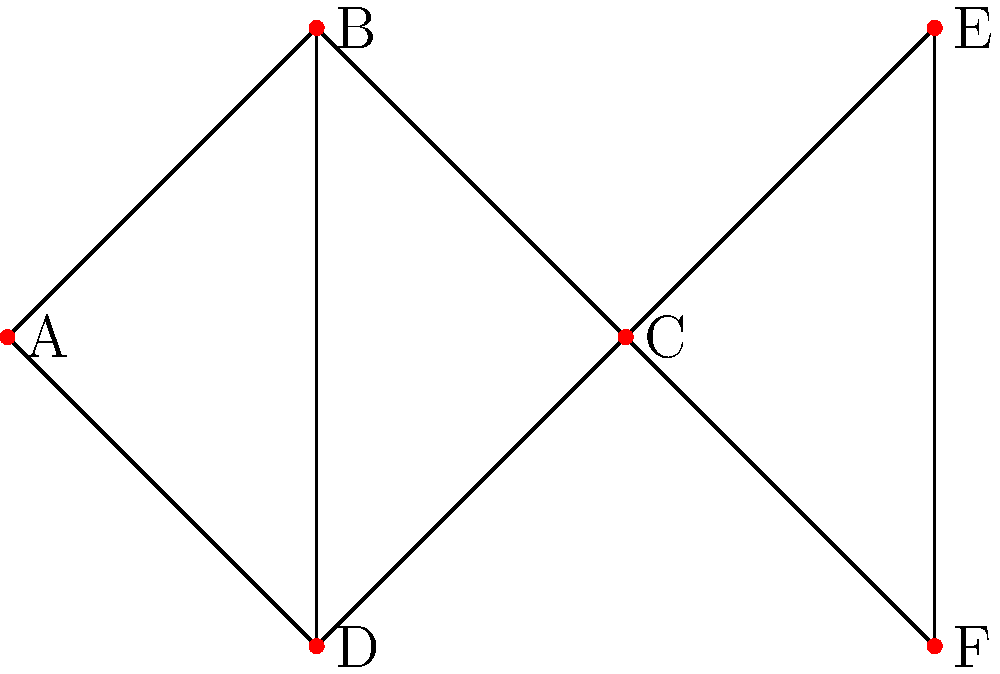As a proactive manager analyzing team communication channels, you're presented with the above undirected graph representing connections between team members. If team member C becomes unavailable, what is the minimum number of additional connections needed to ensure all remaining team members can still communicate with each other, either directly or indirectly? To solve this problem, we need to follow these steps:

1. Identify the current connections:
   - A is connected to B and D
   - B is connected to A, C, and D
   - C is connected to B, E, and F
   - D is connected to A and B
   - E is connected to C and F
   - F is connected to C and E

2. Remove node C and its connections:
   - B loses connection to C
   - E loses connection to C
   - F loses connection to C

3. Analyze the remaining graph:
   - Group 1: A, B, and D are still connected
   - Group 2: E and F are still connected
   - There is no connection between these two groups

4. Determine the minimum number of connections needed:
   - To connect the two groups, we need at least one connection
   - The most efficient way is to connect any node from Group 1 (A, B, or D) to any node from Group 2 (E or F)

5. Conclusion:
   - Only one additional connection is needed to ensure all remaining team members can communicate with each other, either directly or indirectly

This solution demonstrates the importance of redundancy in communication networks and how a single connection can bridge isolated groups, which is valuable knowledge for a proactive manager focused on process improvement.
Answer: 1 